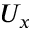Convert formula to latex. <formula><loc_0><loc_0><loc_500><loc_500>U _ { x }</formula> 